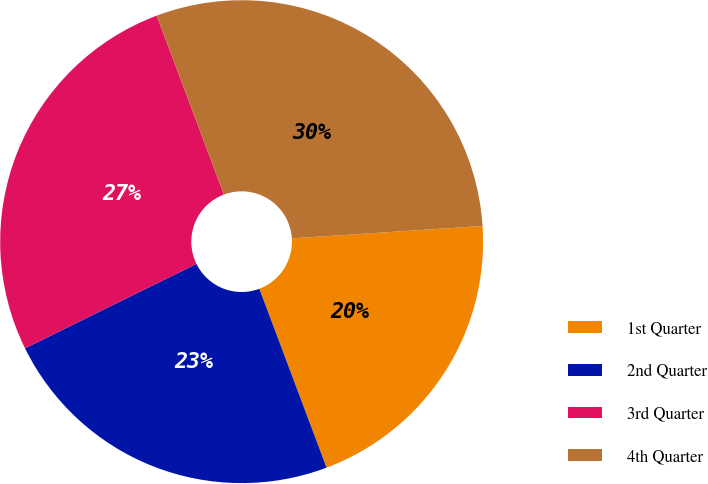Convert chart. <chart><loc_0><loc_0><loc_500><loc_500><pie_chart><fcel>1st Quarter<fcel>2nd Quarter<fcel>3rd Quarter<fcel>4th Quarter<nl><fcel>20.31%<fcel>23.44%<fcel>26.56%<fcel>29.69%<nl></chart> 